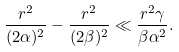<formula> <loc_0><loc_0><loc_500><loc_500>\frac { r ^ { 2 } } { ( 2 \alpha ) ^ { 2 } } - \frac { r ^ { 2 } } { ( 2 \beta ) ^ { 2 } } \ll \frac { r ^ { 2 } \gamma } { \beta \alpha ^ { 2 } } .</formula> 